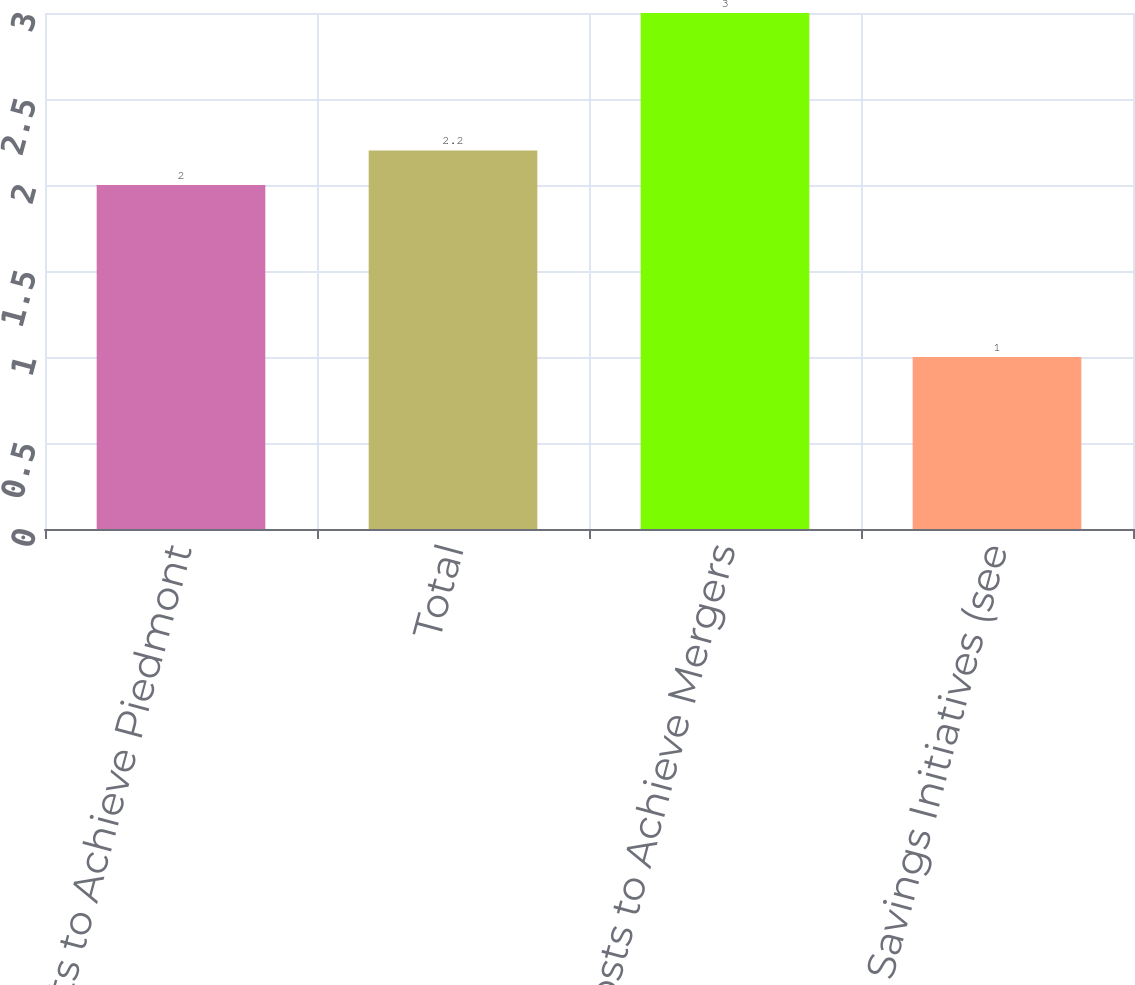Convert chart to OTSL. <chart><loc_0><loc_0><loc_500><loc_500><bar_chart><fcel>Costs to Achieve Piedmont<fcel>Total<fcel>Costs to Achieve Mergers<fcel>Cost Savings Initiatives (see<nl><fcel>2<fcel>2.2<fcel>3<fcel>1<nl></chart> 